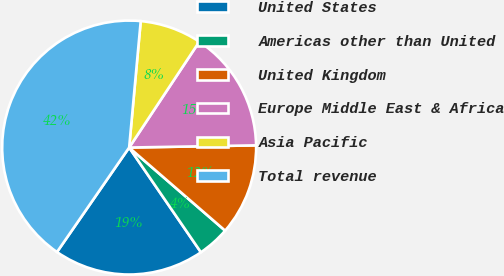Convert chart. <chart><loc_0><loc_0><loc_500><loc_500><pie_chart><fcel>United States<fcel>Americas other than United<fcel>United Kingdom<fcel>Europe Middle East & Africa<fcel>Asia Pacific<fcel>Total revenue<nl><fcel>19.18%<fcel>4.08%<fcel>11.63%<fcel>15.41%<fcel>7.86%<fcel>41.83%<nl></chart> 